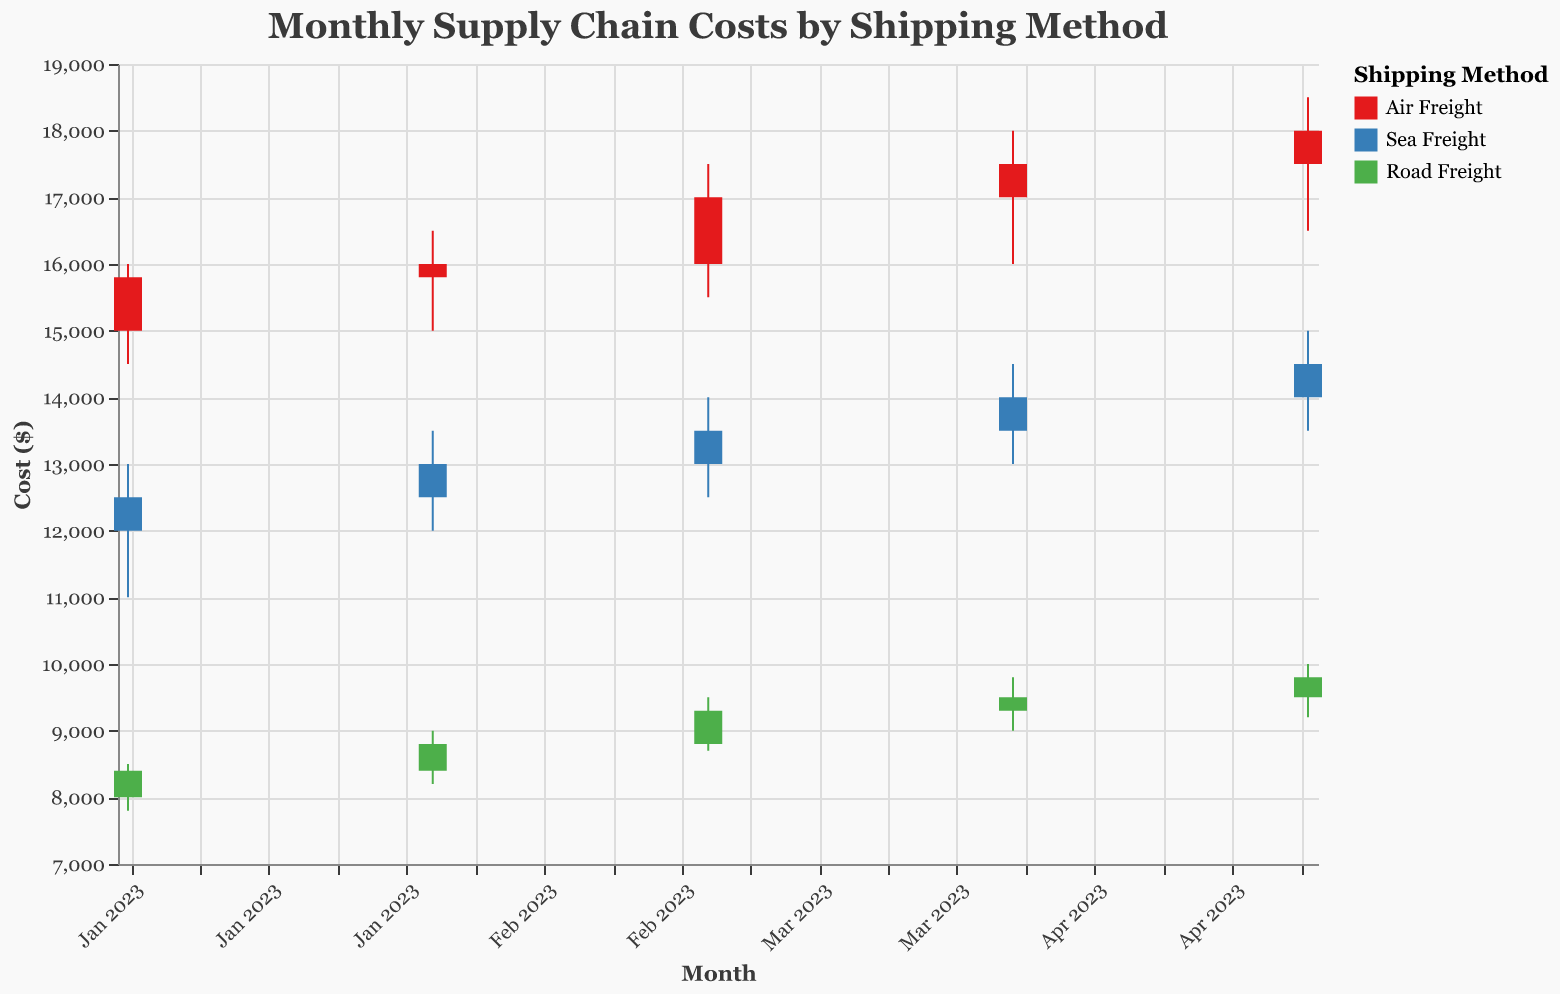What's the title of the figure? The title is written at the top of the figure and prominently displays the main topic of the chart to help viewers understand the content quickly.
Answer: Monthly Supply Chain Costs by Shipping Method Which shipping method had the highest cost in March 2023? To find the highest cost for March 2023, look at the "High" values for each shipping method in that month.
Answer: Air Freight What was the lowest cost for Sea Freight in January 2023? Locate January 2023 in the x-axis, and then find the "Low" value for Sea Freight among the data points listed for that month.
Answer: 11000 Between April and May 2023, how did the closing cost for Road Freight change? Compare the "Close" values for Road Freight in April and May 2023 by looking at the respective closing costs. The change can be calculated by subtracting the April closing cost from the May closing cost.
Answer: It increased by 300 What was the opening cost for Air Freight in February 2023? Find February 2023 on the x-axis and look for the "Open" value for Air Freight.
Answer: 15800 Between January and May 2023, which shipping method showed the most consistent high costs? Evaluate the "High" costs for each shipping method from January to May 2023. Consistency means less variation in the high costs over the months.
Answer: Air Freight How did the maximum and minimum costs for Sea Freight change from January to May 2023? Compare the "High" and "Low" values for Sea Freight in January and May to understand the changes. Subtract January's maximum from May's maximum, and January's minimum from May's minimum to identify changes.
Answer: High increased by 2000, Low increased by 2500 Which month had the highest closing cost for all three shipping methods combined? Add the "Close" values for all shipping methods for each month and compare these sums to find the month with the highest total closing cost.
Answer: May 2023 What was the range of costs for Road Freight in February 2023? To calculate the range, find the highest and lowest costs for Road Freight in February and subtract the lowest from the highest.
Answer: 1800 Which shipping method had the smallest difference between the opening and closing costs in April 2023? Calculate the absolute difference between the "Open" and "Close" values for each shipping method in April 2023, and identify the smallest difference.
Answer: Sea Freight 